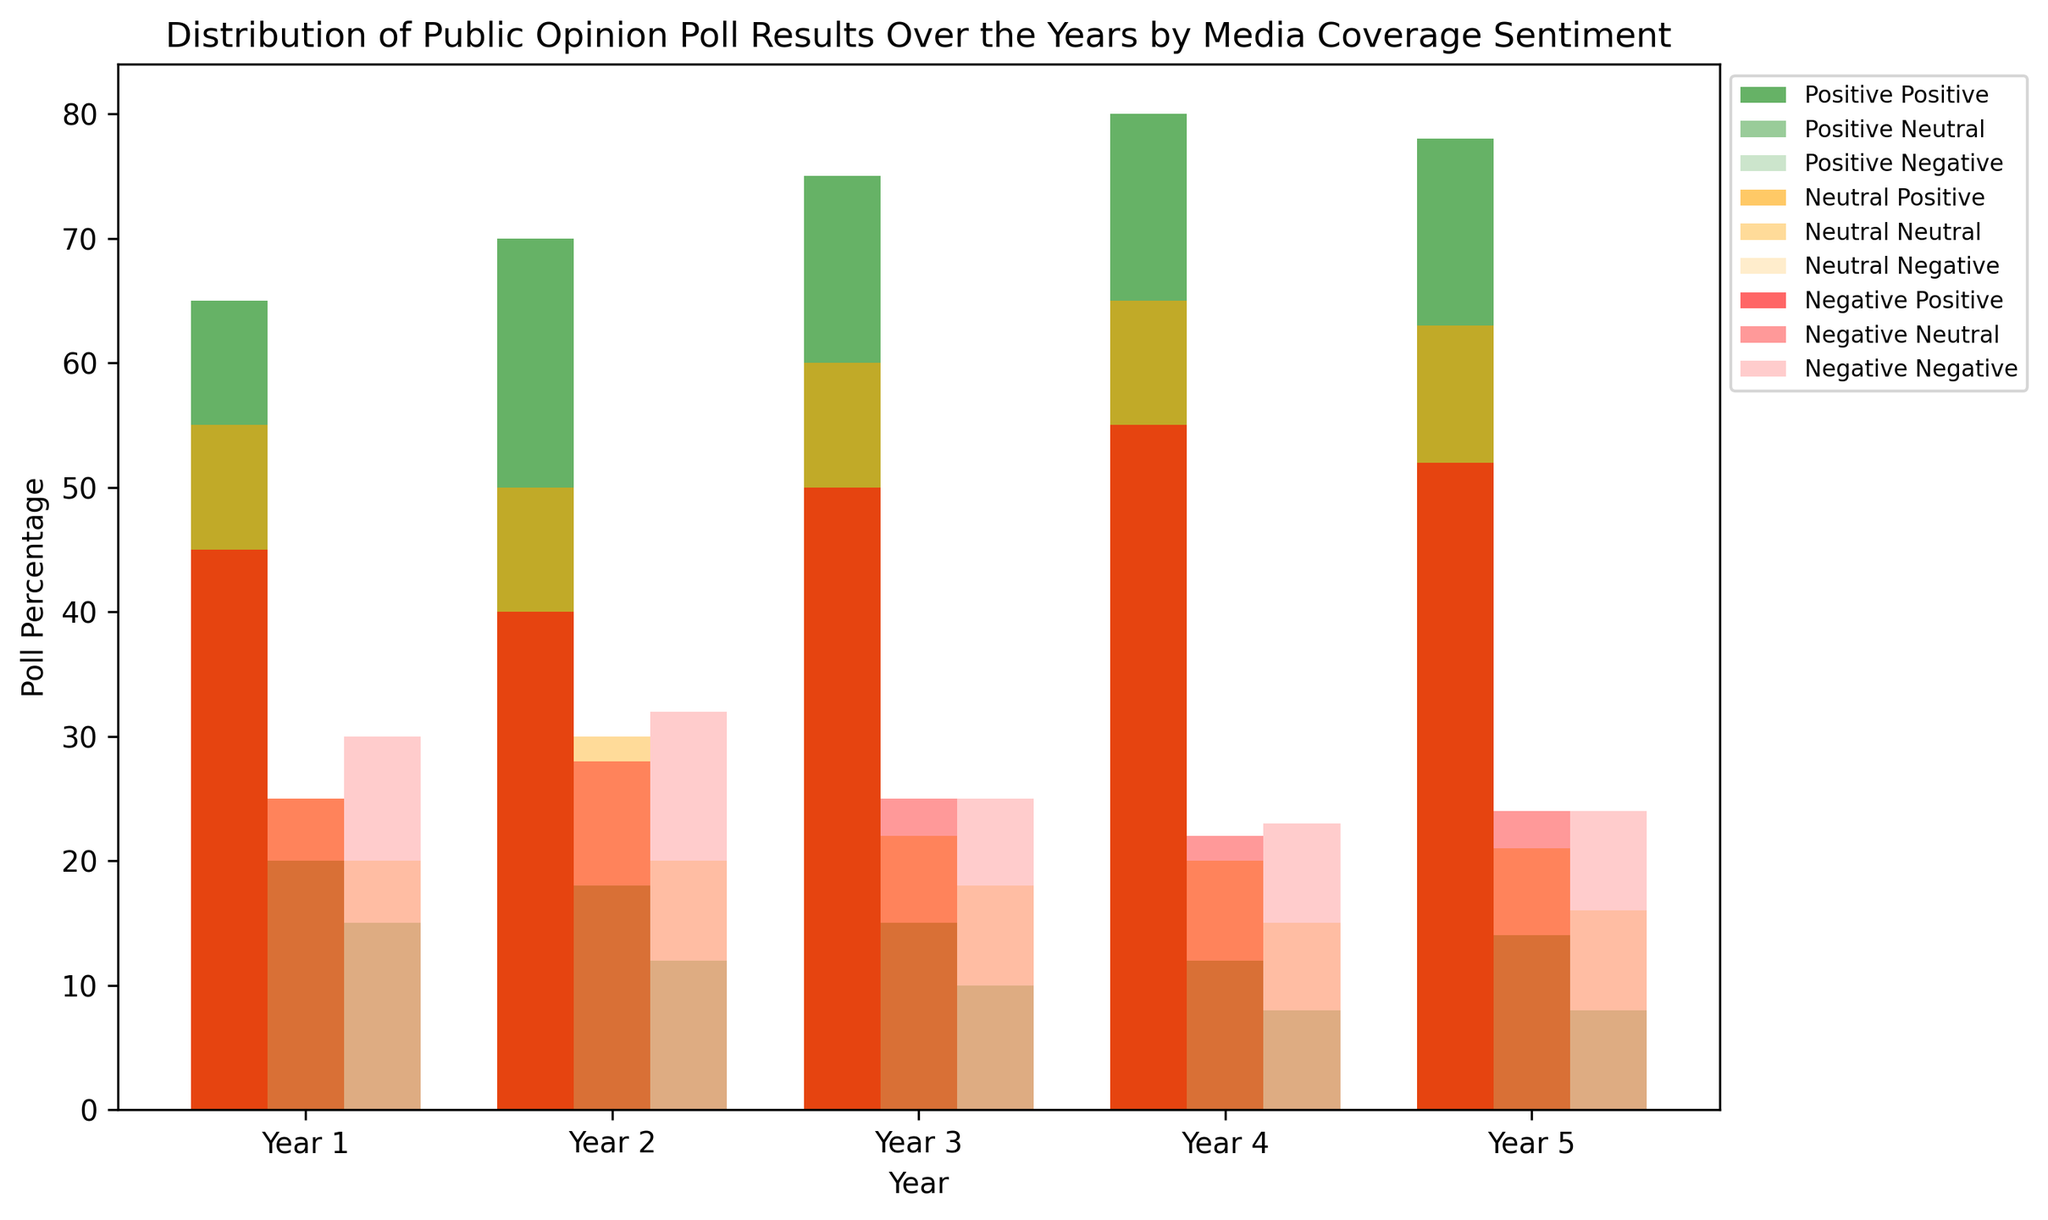Which media coverage sentiment had the highest positive poll percentage in Year 3? To determine this, observe the bars representing positive poll percentages for each media coverage sentiment in Year 3 (green bars). The 'Positive' sentiment had the highest bar.
Answer: Positive In Year 4, which sentiment had a higher neutral poll percentage: Positive or Negative? Compare the heights of the orange bars for 'Positive' and 'Negative' sentiments in Year 4. The 'Negative' sentiment has a higher orange bar.
Answer: Negative Which year had the lowest negative poll percentage for the Positive sentiment? Track the green bar's position in each year and identify the shortest red bar within those categories. In Year 3 (10%) the 'Positive' sentiment's negative poll percentage is the lowest.
Answer: Year 3 What is the average positive poll percentage across all years for the Neutral sentiment? Sum up the positive poll percentages for the Neutral sentiment across all years: (55+50+60+65+63) = 293. Then, divide by the number of years (5). 293 / 5 = 58.6%
Answer: 58.6% In Year 5, compare the negative poll percentages among the three sentiments and identify the sentiment with the highest percentage. Examine the red bars for Year 5 in all three sentiment categories. The 'Negative' sentiment has the highest percentage with a 24% negative poll.
Answer: Negative Which sentiment shows a consistent increase in positive poll percentage over the five years? Observe the green bars for each sentiment across the years. The 'Positive' sentiment category shows a consistent increase each year.
Answer: Positive How much did the positive poll percentage for the 'Neutral' sentiment change from Year 1 to Year 4? Find the difference between the heights of Year 4 and Year 1 green bars in the Neutral category: 65% - 55% = 10%.
Answer: 10% Which year had the highest overall neutral poll percentage across all sentiments? Compare the overall heights of orange bars each year, regardless of sentiment. Year 2 has the highest neutral poll percentage with 30% in the Neutral sentiment.
Answer: Year 2 Calculate the difference between the positive poll percentages of the Positive sentiment between Year 1 and Year 5. Subtract the Year 1 positive poll percentage from Year 5 in the Positive sentiment: 78% - 65% = 13%.
Answer: 13% In Year 2, how does the neutral poll percentage of the Positive sentiment compare to the negative poll percentage of the Negative sentiment? Compare the heights of the orange bar for 'Positive' and the red bar for 'Negative' in Year 2. The 'Positive' sentiment has 18% and the 'Negative' sentiment has 32%. Thus, 18% < 32%.
Answer: Less than 